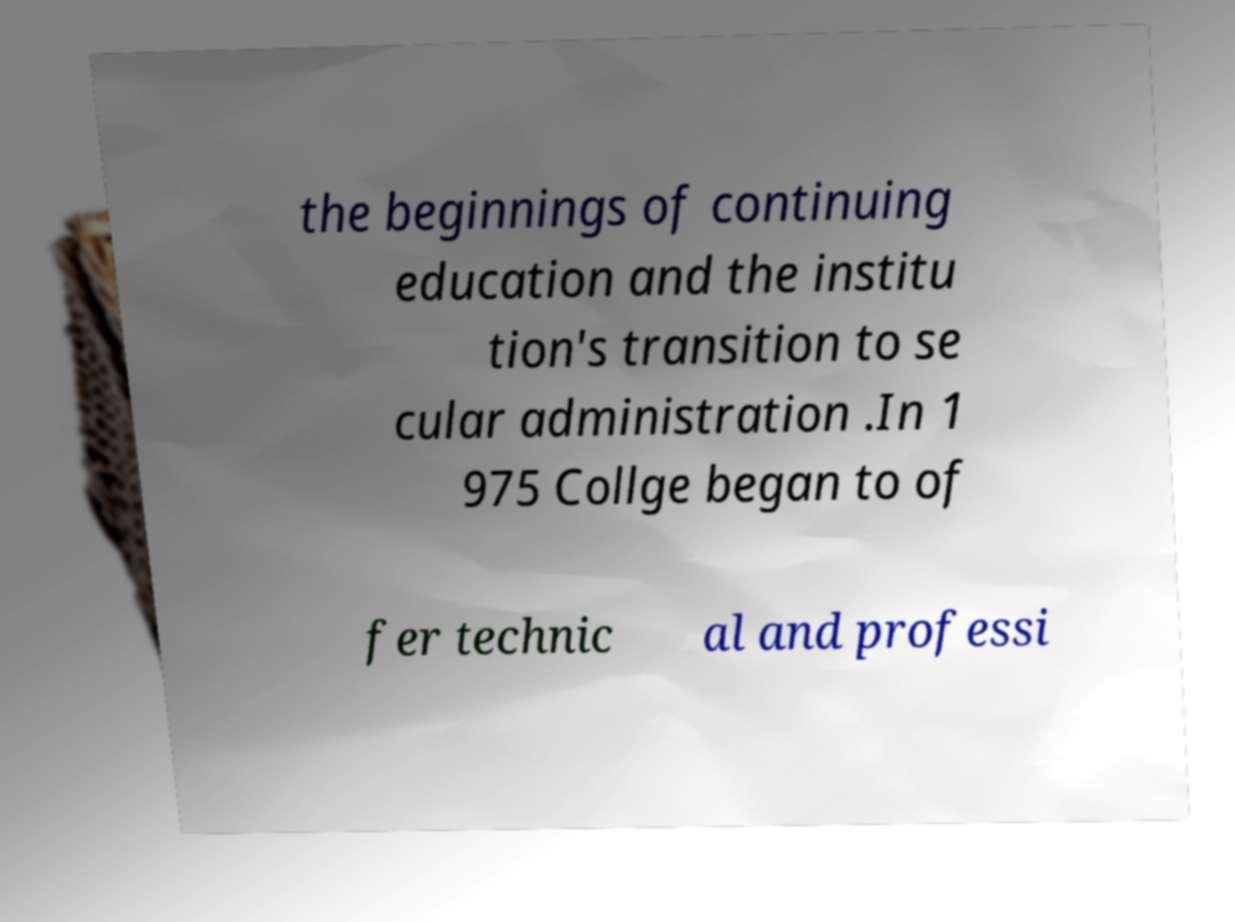Could you assist in decoding the text presented in this image and type it out clearly? the beginnings of continuing education and the institu tion's transition to se cular administration .In 1 975 Collge began to of fer technic al and professi 